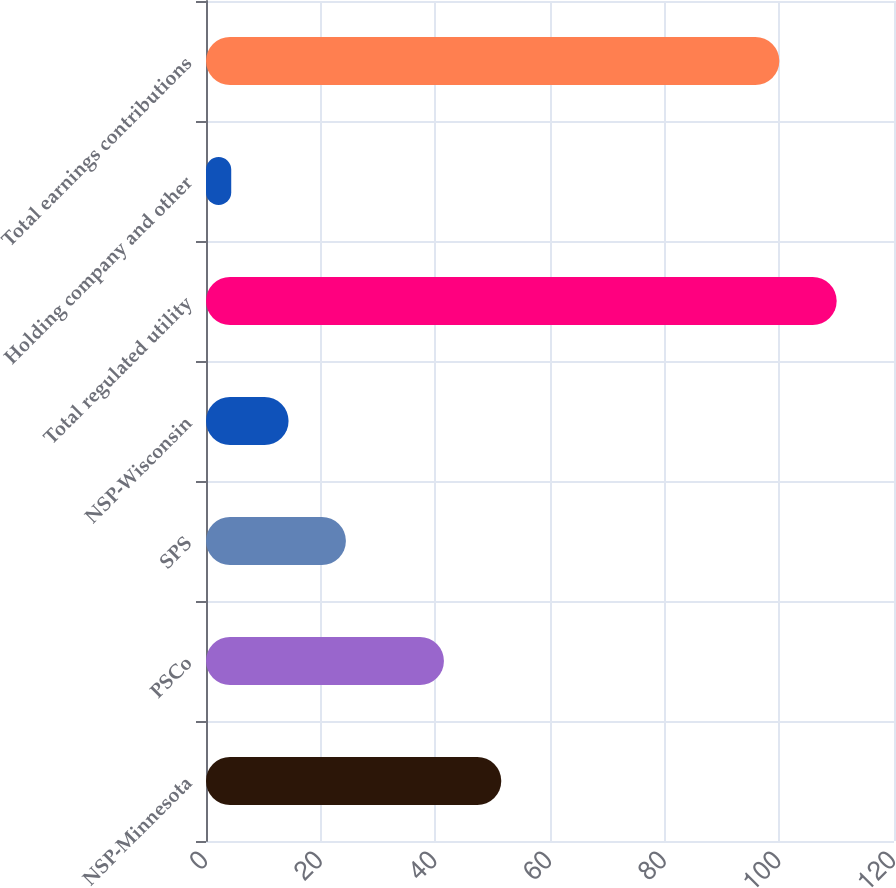<chart> <loc_0><loc_0><loc_500><loc_500><bar_chart><fcel>NSP-Minnesota<fcel>PSCo<fcel>SPS<fcel>NSP-Wisconsin<fcel>Total regulated utility<fcel>Holding company and other<fcel>Total earnings contributions<nl><fcel>51.5<fcel>41.5<fcel>24.4<fcel>14.4<fcel>110<fcel>4.4<fcel>100<nl></chart> 